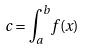<formula> <loc_0><loc_0><loc_500><loc_500>c = \int _ { a } ^ { b } f ( x )</formula> 